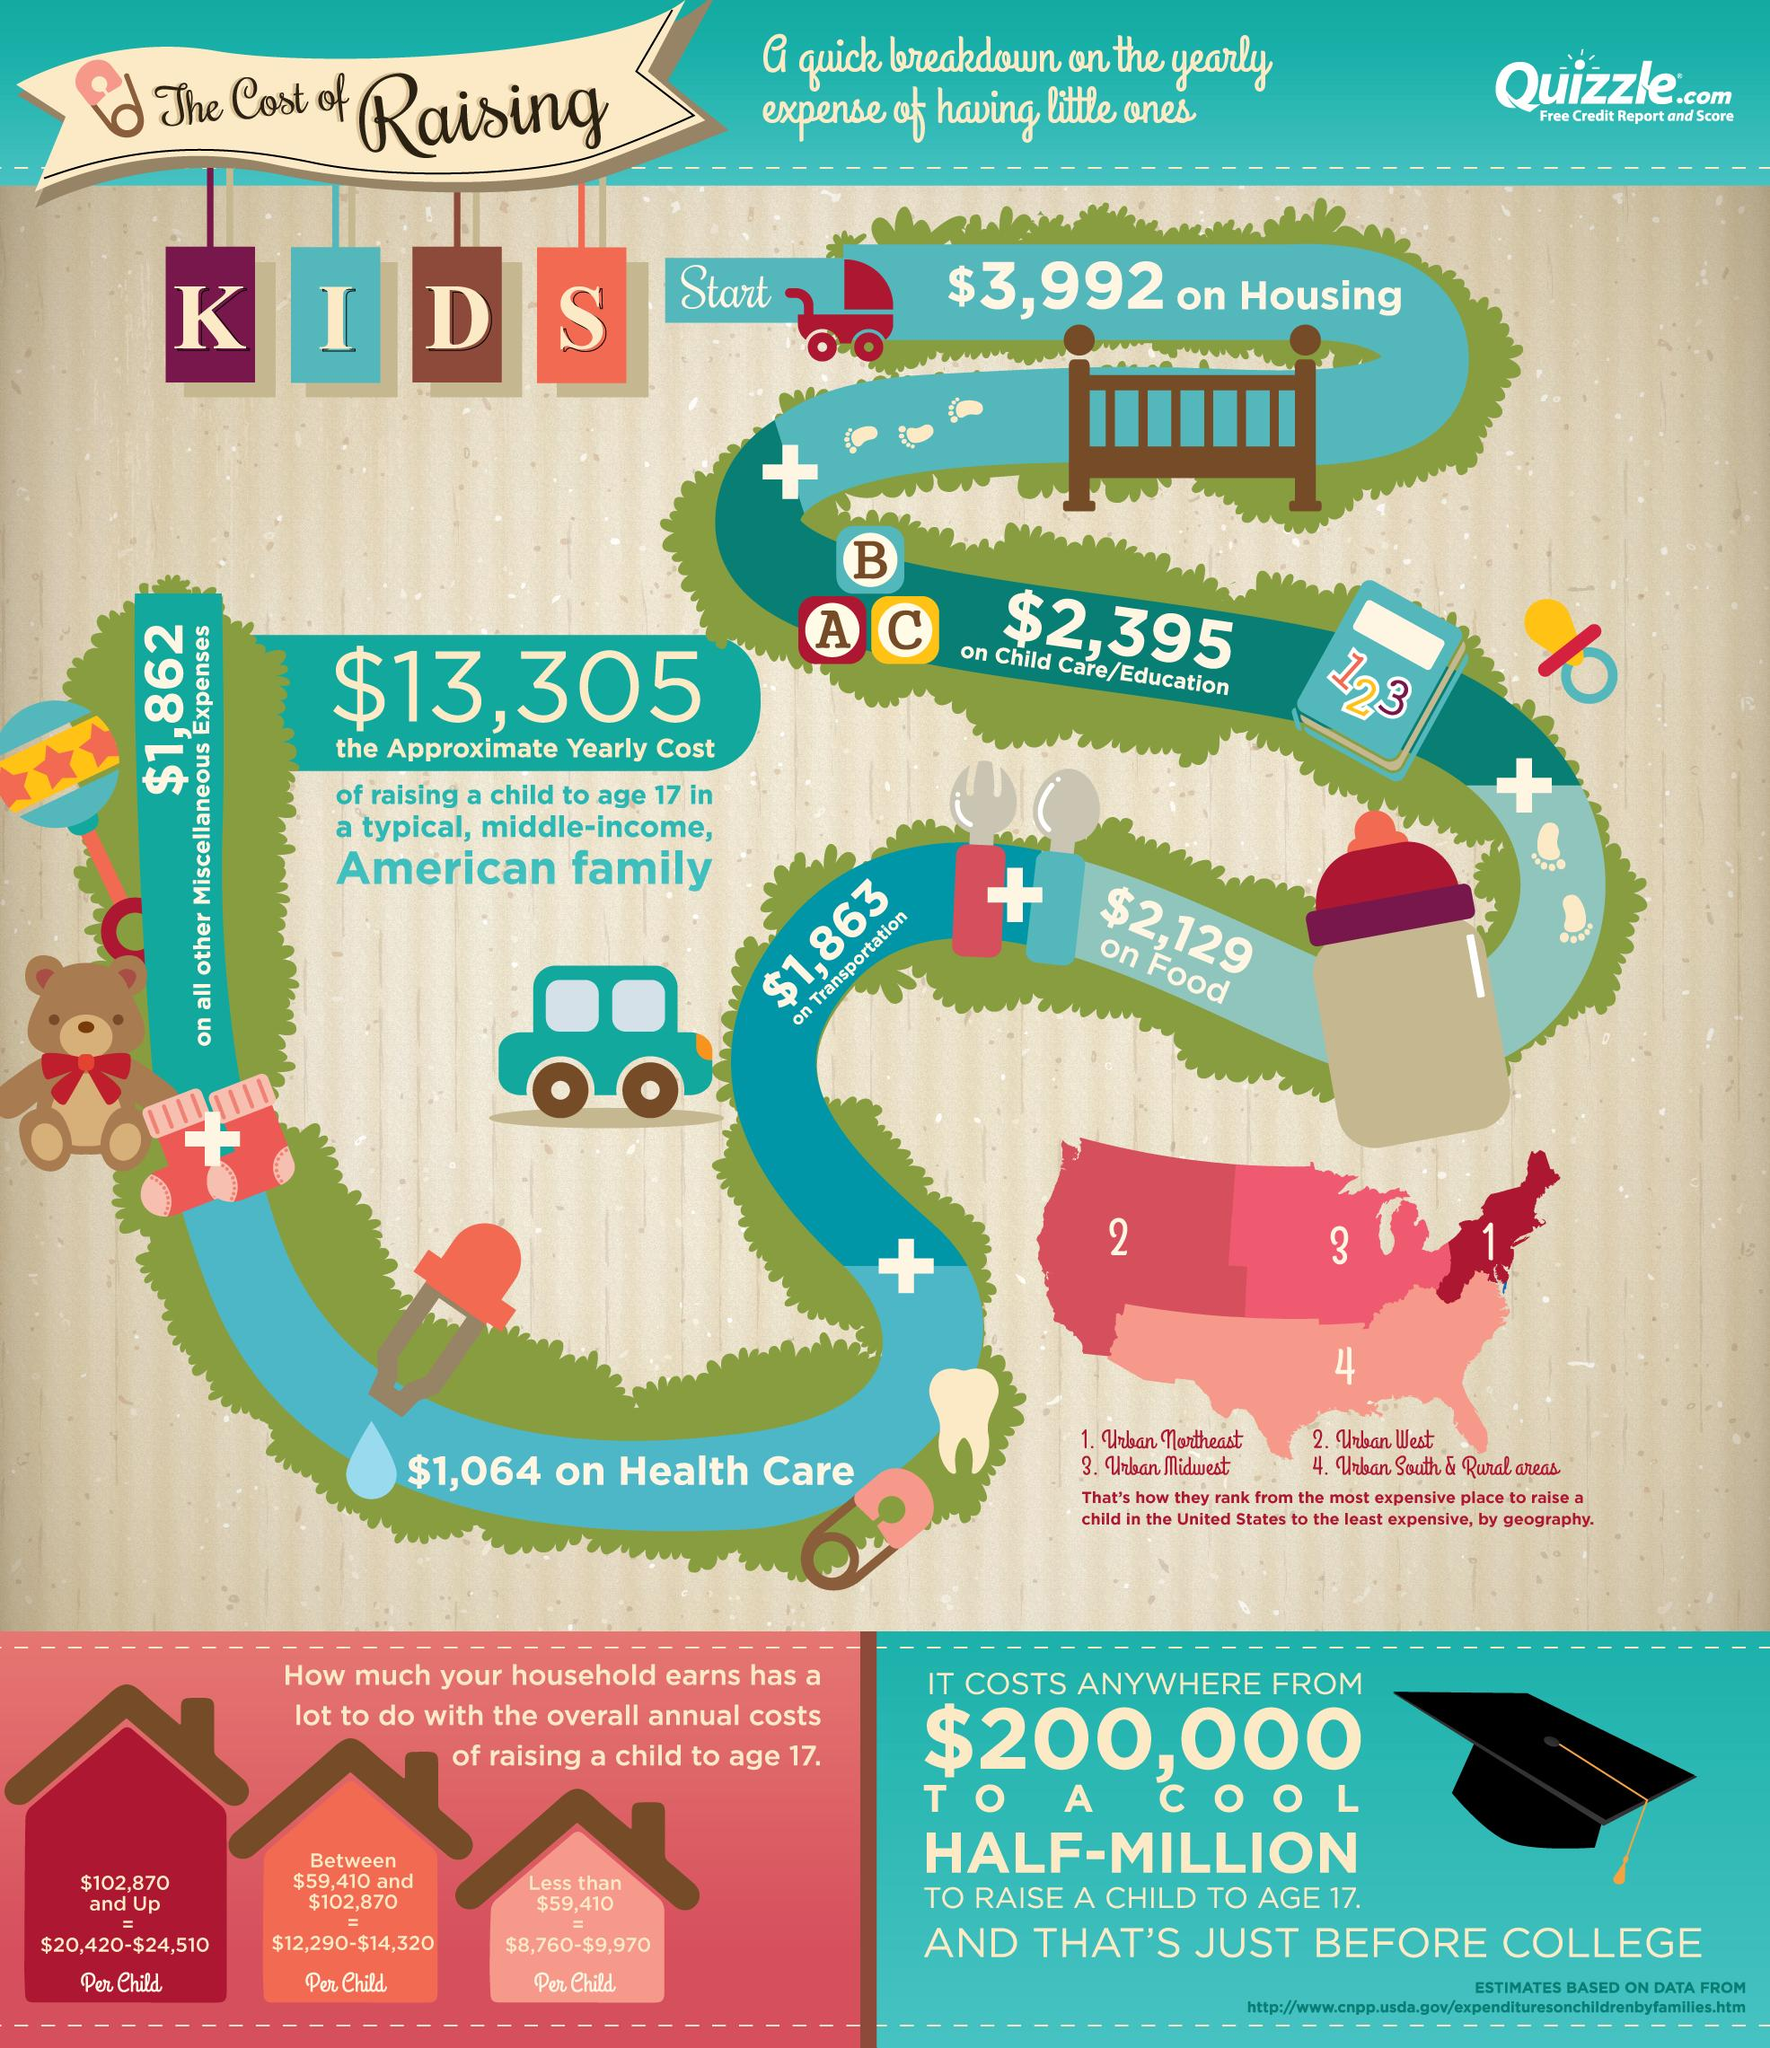Give some essential details in this illustration. The approximate yearly cost for child care and education for a child in a typical, middle-income, American family is approximately $2,395, according to recent data. The approximate yearly cost for food for a child in a typical, middle-income, American family is approximately $2,129. The approximate yearly cost for transportation for a child in a typical, middle-income, American family is $1,863. The approximate yearly cost for housing for a child in a typical, middle-income, American family is $3,992. According to a recent estimate, the typical, middle-income, American family can expect to pay approximately $1,064 per year in health care costs for their child. 